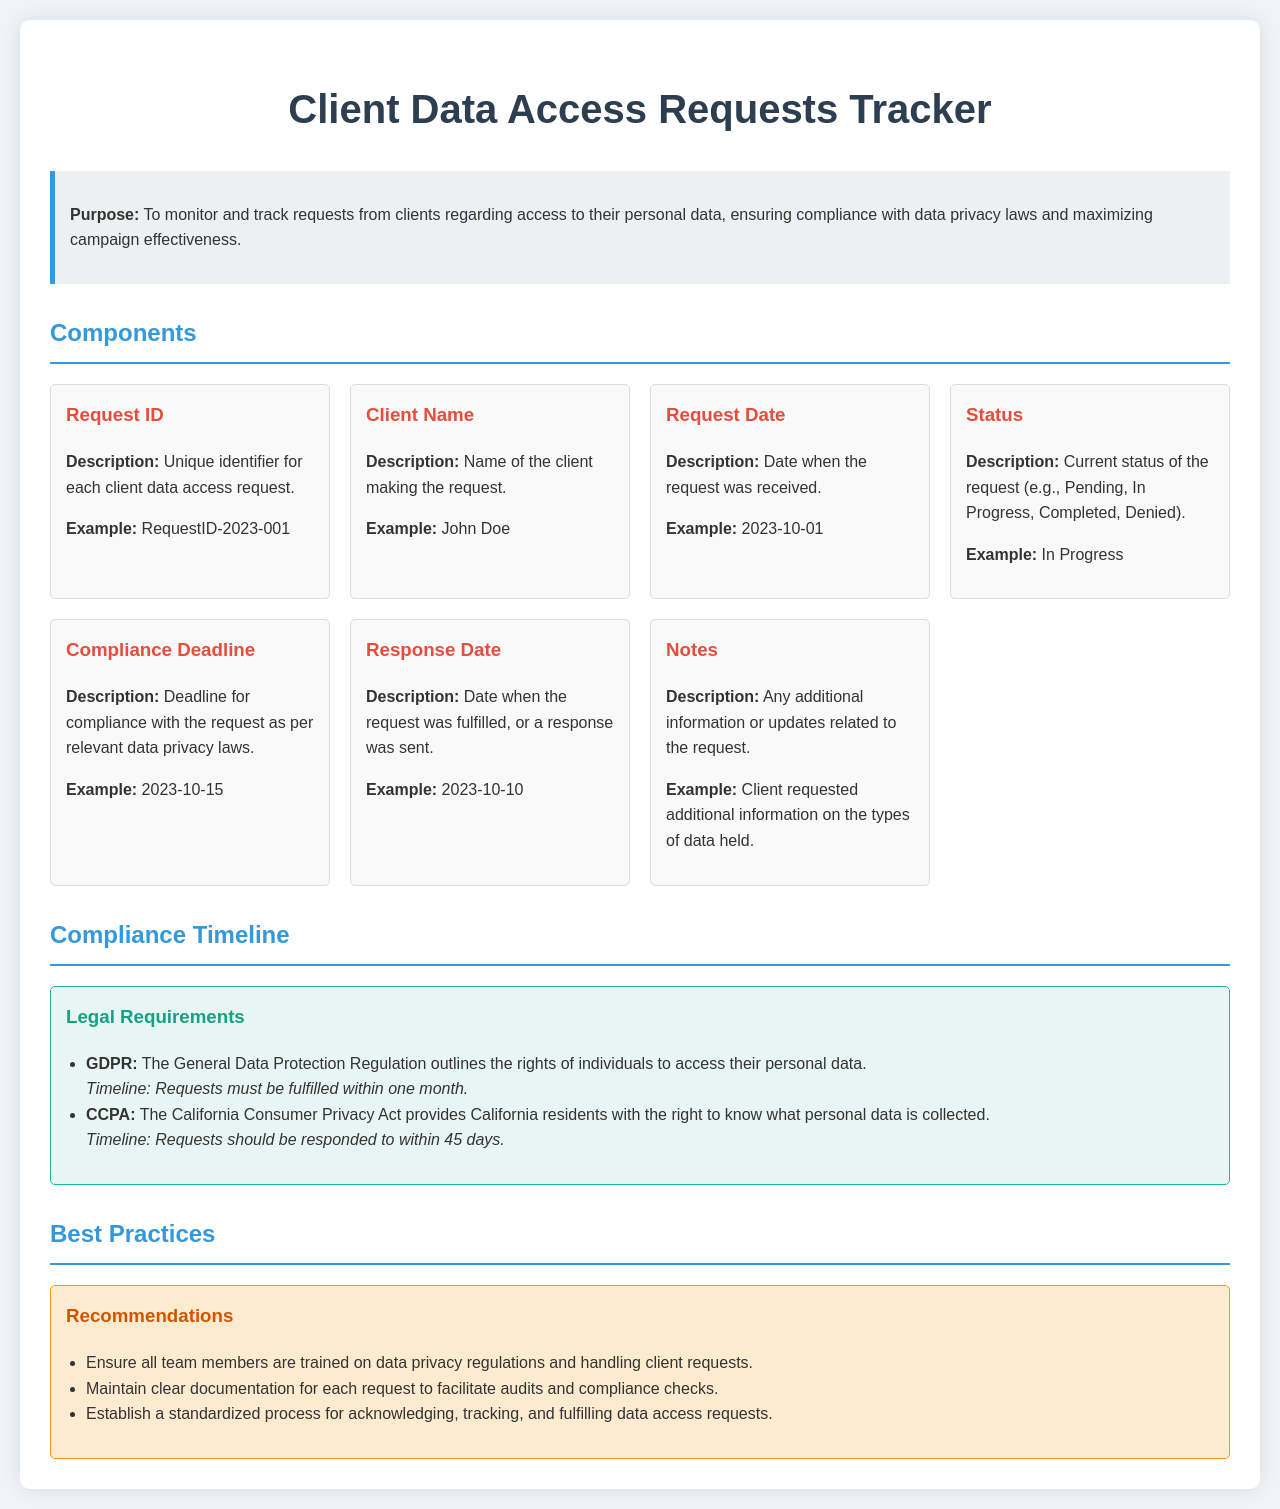what is the purpose of the Client Data Access Requests Tracker? The purpose is to monitor and track requests from clients regarding access to their personal data, ensuring compliance with data privacy laws and maximizing campaign effectiveness.
Answer: monitor and track requests what is an example of a Request ID? The document provides an example for the Request ID format which is seen in the text.
Answer: RequestID-2023-001 what is the status of a request described in the document? The document lists statuses for requests including examples provided.
Answer: In Progress what is the compliance deadline example given? The compliance deadline is mentioned with an illustrative example in the document.
Answer: 2023-10-15 how long do clients have to wait for a GDPR request fulfillment? The document specifies a timeline for fulfilling GDPR requests, which is mentioned distinctly.
Answer: one month what should team members be trained on according to the best practices? The best practices section emphasizes a critical area that team members need to be knowledgeable about.
Answer: data privacy regulations how many days do clients have under CCPA for request response? The document outlines a specific timeline related to CCPA response times, making it clear.
Answer: 45 days what type of information does the 'Notes' section capture? The document describes the purpose of the Notes section regarding client requests.
Answer: additional information what is one of the recommendations for maintaining request documentation? The best practices section suggests important methods for managing documentation effectively.
Answer: facilitate audits and compliance checks 